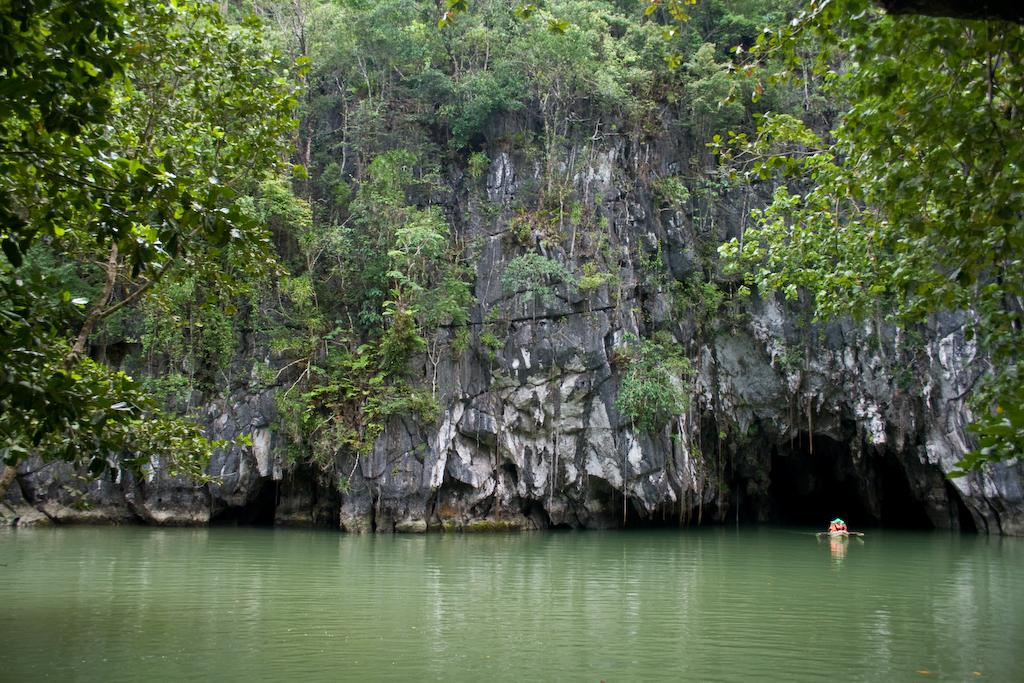What geographical feature is the main subject of the image? There is a hill in the image. What can be found at the bottom of the hill? There is a lake at the bottom of the hill. What type of vegetation is present at the top of the hill? There are trees at the top of the hill. What type of belief is depicted in the image? There is no depiction of a belief in the image; it features a hill, a lake, and trees. What kind of bait is used for fishing in the image? There is no fishing or bait present in the image; it features a hill, a lake, and trees. 